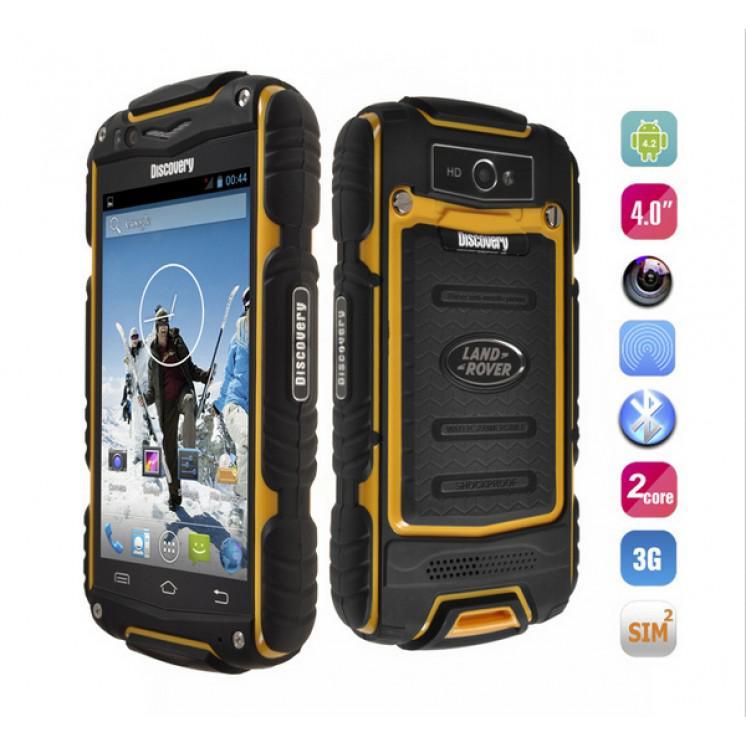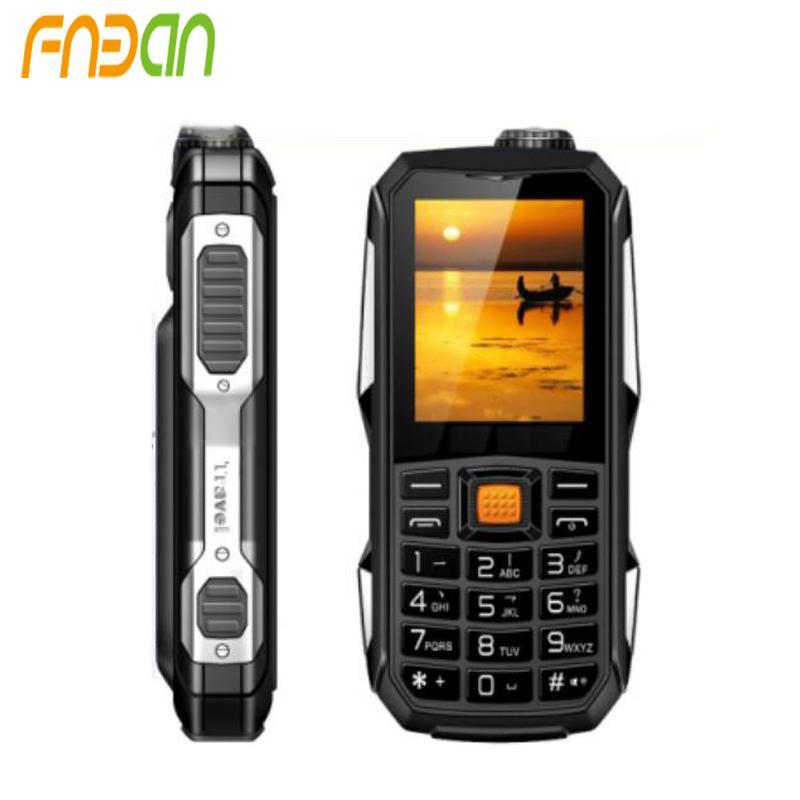The first image is the image on the left, the second image is the image on the right. Assess this claim about the two images: "Both of the images are showing two different views of the same cell phone.". Correct or not? Answer yes or no. Yes. The first image is the image on the left, the second image is the image on the right. For the images shown, is this caption "The back of a phone is visible." true? Answer yes or no. Yes. 